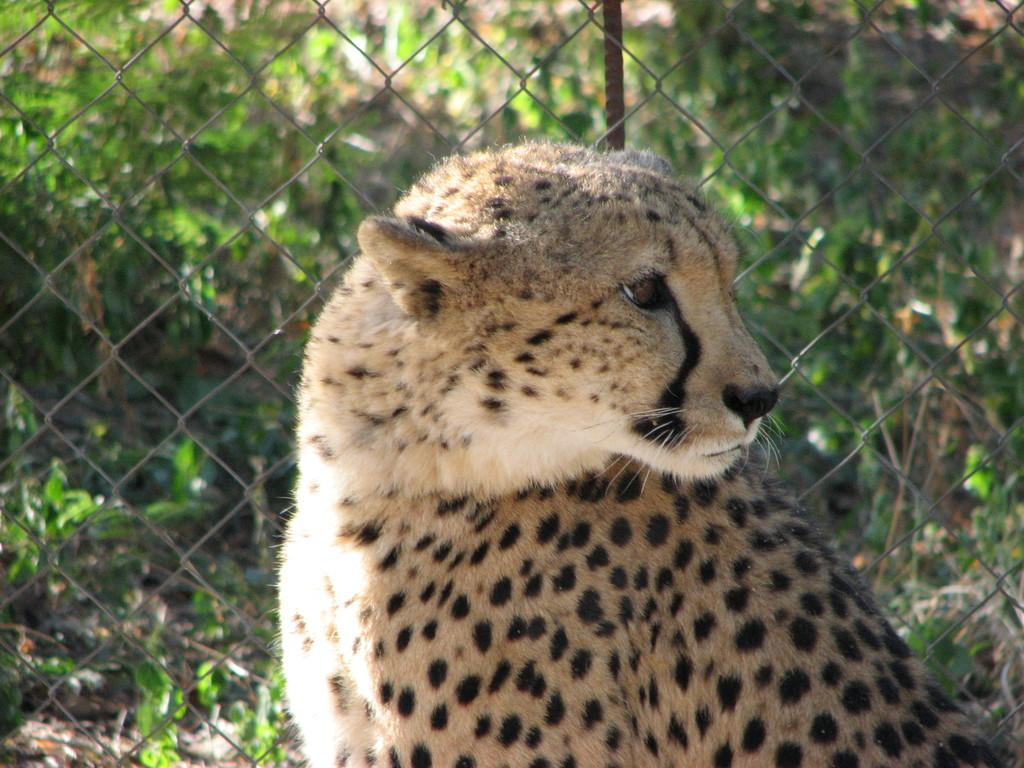What animal is in the center of the image? There is a cheetah in the center of the image. What can be seen behind the cheetah? There is a mesh in the background of the image. What type of vegetation is visible in the background? There are trees visible in the background of the image. What type of lock is holding the cheetah in the image? There is no lock present in the image; the cheetah is not restrained. 